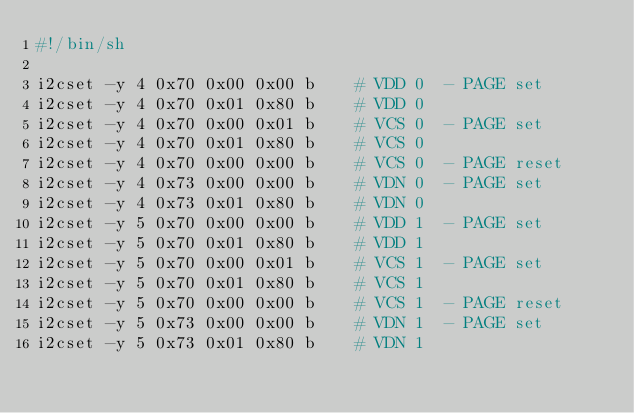<code> <loc_0><loc_0><loc_500><loc_500><_Bash_>#!/bin/sh

i2cset -y 4 0x70 0x00 0x00 b    # VDD 0  - PAGE set
i2cset -y 4 0x70 0x01 0x80 b    # VDD 0
i2cset -y 4 0x70 0x00 0x01 b    # VCS 0  - PAGE set
i2cset -y 4 0x70 0x01 0x80 b    # VCS 0
i2cset -y 4 0x70 0x00 0x00 b    # VCS 0  - PAGE reset
i2cset -y 4 0x73 0x00 0x00 b    # VDN 0  - PAGE set
i2cset -y 4 0x73 0x01 0x80 b    # VDN 0
i2cset -y 5 0x70 0x00 0x00 b    # VDD 1  - PAGE set
i2cset -y 5 0x70 0x01 0x80 b    # VDD 1
i2cset -y 5 0x70 0x00 0x01 b    # VCS 1  - PAGE set
i2cset -y 5 0x70 0x01 0x80 b    # VCS 1
i2cset -y 5 0x70 0x00 0x00 b    # VCS 1  - PAGE reset
i2cset -y 5 0x73 0x00 0x00 b    # VDN 1  - PAGE set
i2cset -y 5 0x73 0x01 0x80 b    # VDN 1
</code> 